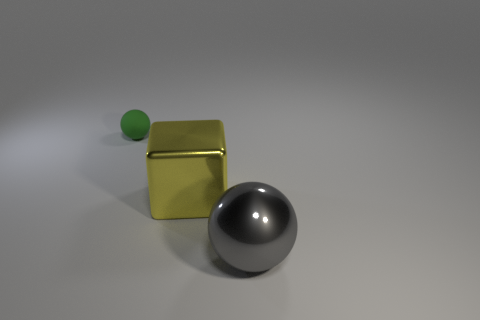Add 1 small red matte cylinders. How many objects exist? 4 Subtract all cubes. How many objects are left? 2 Subtract all small cyan metal things. Subtract all yellow shiny cubes. How many objects are left? 2 Add 2 green balls. How many green balls are left? 3 Add 1 blue matte spheres. How many blue matte spheres exist? 1 Subtract 0 blue cubes. How many objects are left? 3 